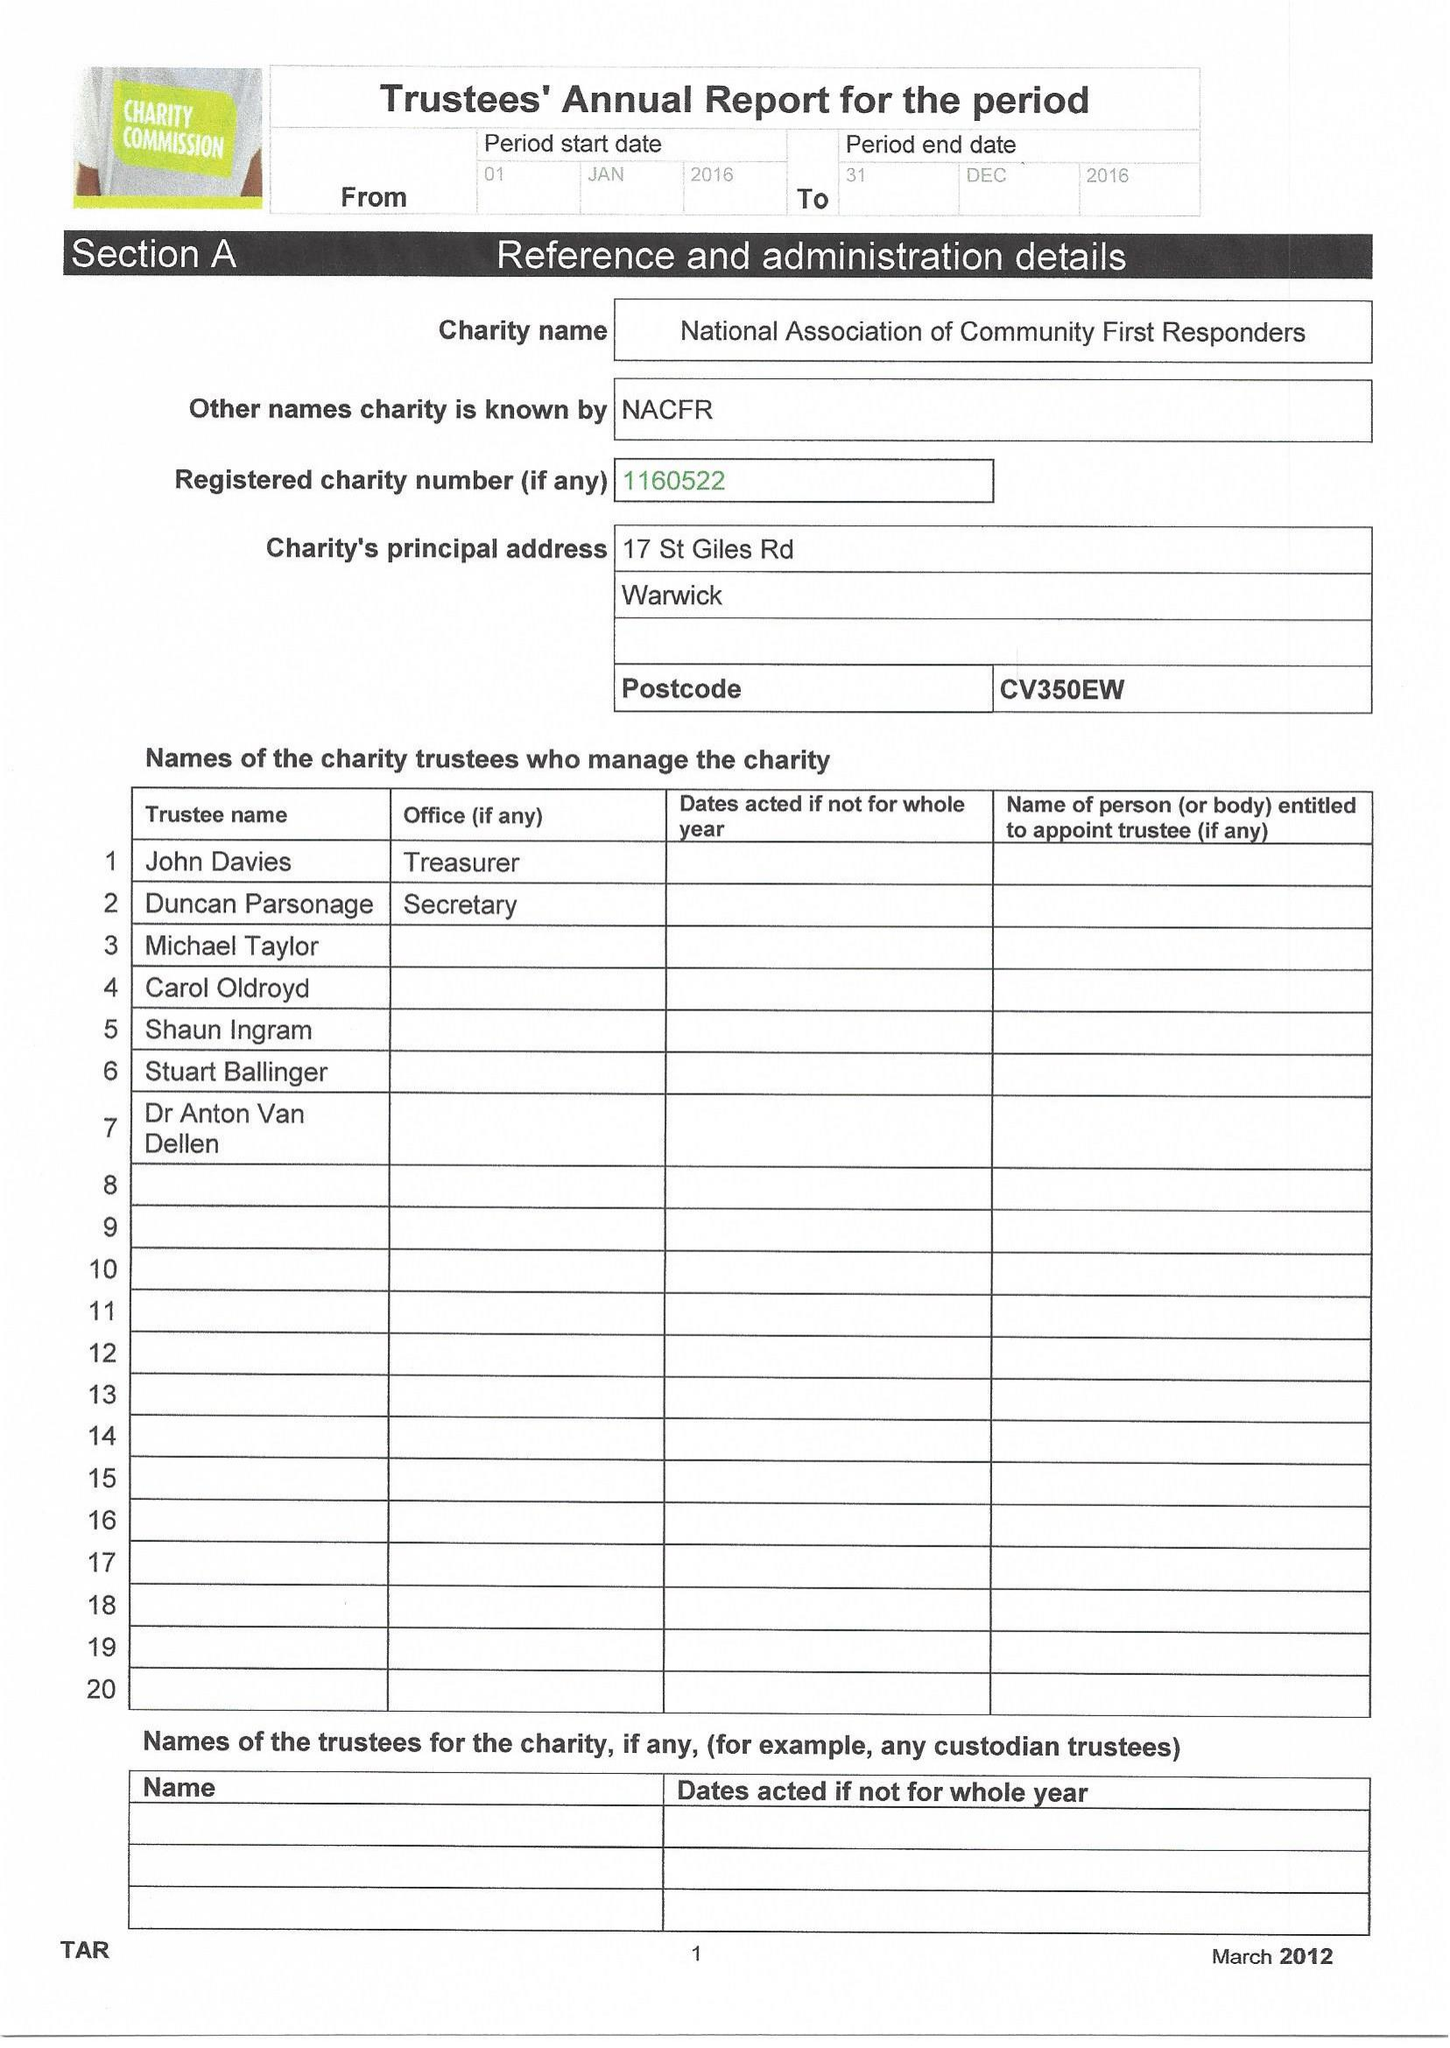What is the value for the spending_annually_in_british_pounds?
Answer the question using a single word or phrase. None 